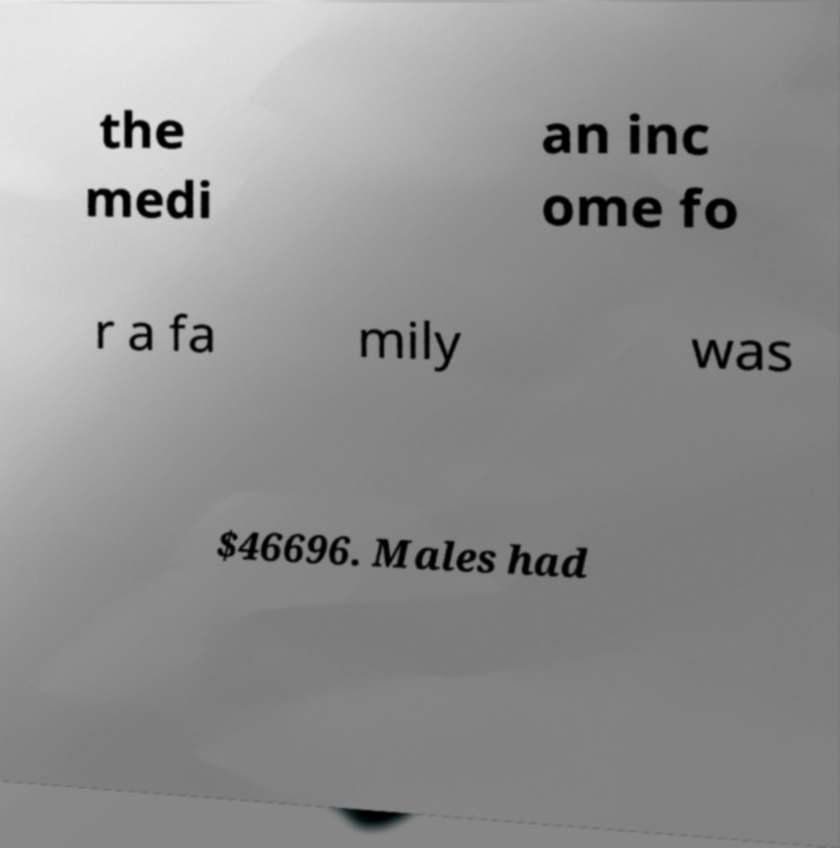What messages or text are displayed in this image? I need them in a readable, typed format. the medi an inc ome fo r a fa mily was $46696. Males had 